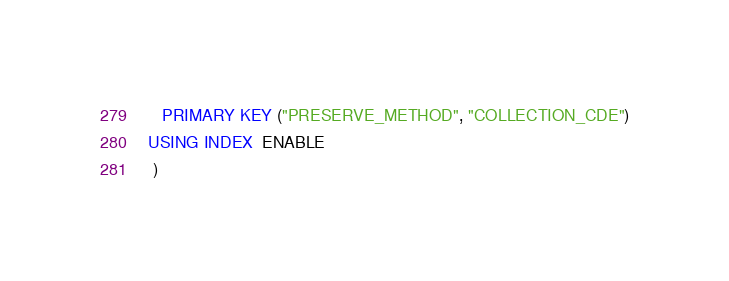Convert code to text. <code><loc_0><loc_0><loc_500><loc_500><_SQL_>	 PRIMARY KEY ("PRESERVE_METHOD", "COLLECTION_CDE")
  USING INDEX  ENABLE
   ) </code> 